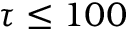<formula> <loc_0><loc_0><loc_500><loc_500>\tau \leq 1 0 0</formula> 